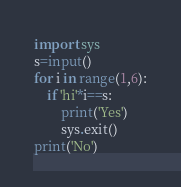Convert code to text. <code><loc_0><loc_0><loc_500><loc_500><_Python_>import sys
s=input()
for i in range(1,6):
    if 'hi'*i==s:
        print('Yes')
        sys.exit()
print('No')
</code> 